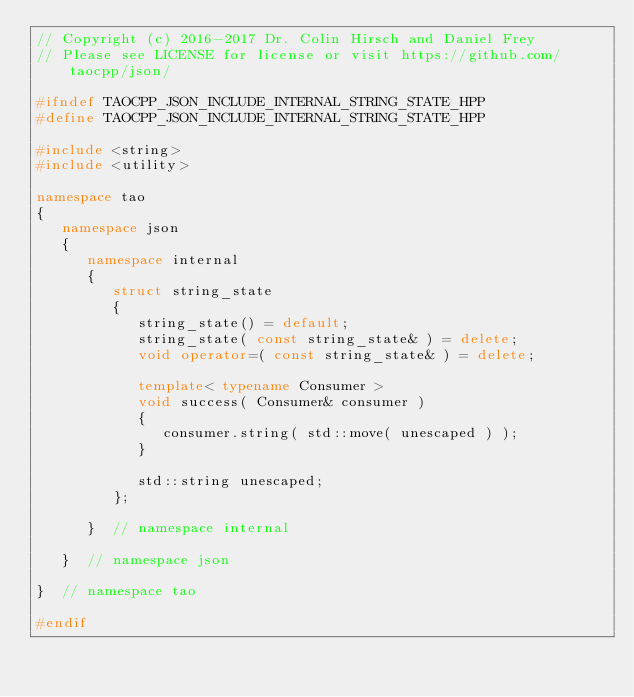<code> <loc_0><loc_0><loc_500><loc_500><_C++_>// Copyright (c) 2016-2017 Dr. Colin Hirsch and Daniel Frey
// Please see LICENSE for license or visit https://github.com/taocpp/json/

#ifndef TAOCPP_JSON_INCLUDE_INTERNAL_STRING_STATE_HPP
#define TAOCPP_JSON_INCLUDE_INTERNAL_STRING_STATE_HPP

#include <string>
#include <utility>

namespace tao
{
   namespace json
   {
      namespace internal
      {
         struct string_state
         {
            string_state() = default;
            string_state( const string_state& ) = delete;
            void operator=( const string_state& ) = delete;

            template< typename Consumer >
            void success( Consumer& consumer )
            {
               consumer.string( std::move( unescaped ) );
            }

            std::string unescaped;
         };

      }  // namespace internal

   }  // namespace json

}  // namespace tao

#endif
</code> 